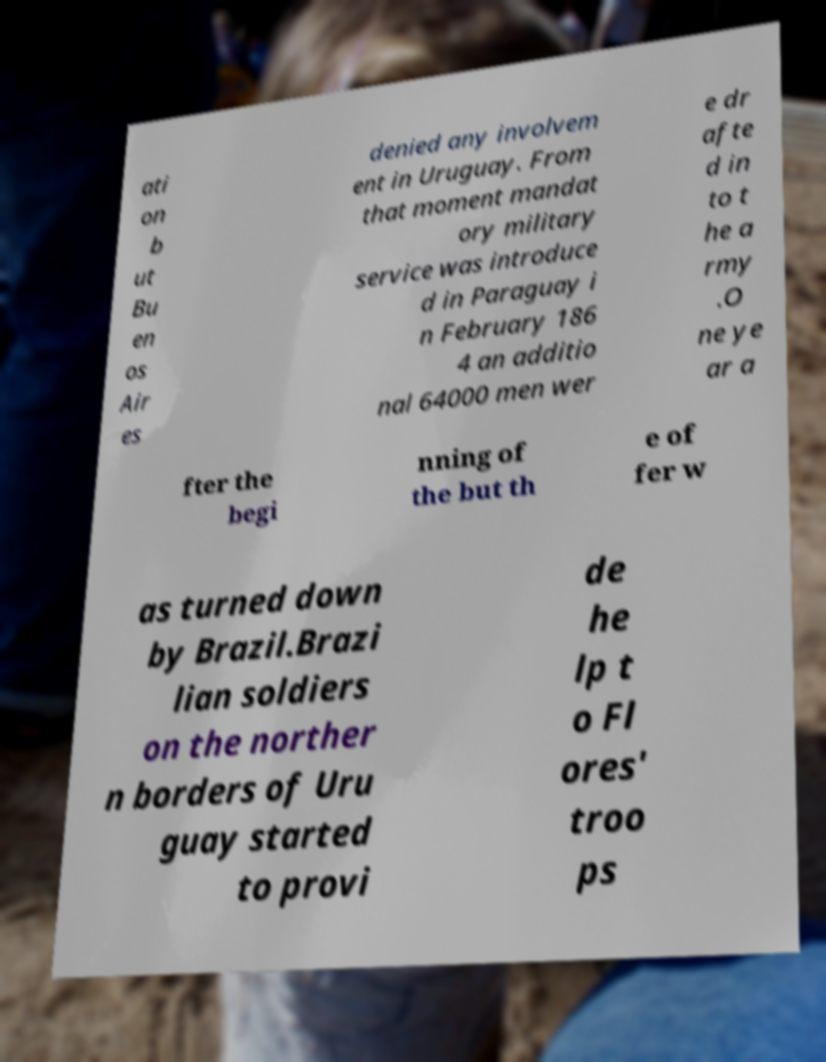Can you read and provide the text displayed in the image?This photo seems to have some interesting text. Can you extract and type it out for me? ati on b ut Bu en os Air es denied any involvem ent in Uruguay. From that moment mandat ory military service was introduce d in Paraguay i n February 186 4 an additio nal 64000 men wer e dr afte d in to t he a rmy .O ne ye ar a fter the begi nning of the but th e of fer w as turned down by Brazil.Brazi lian soldiers on the norther n borders of Uru guay started to provi de he lp t o Fl ores' troo ps 